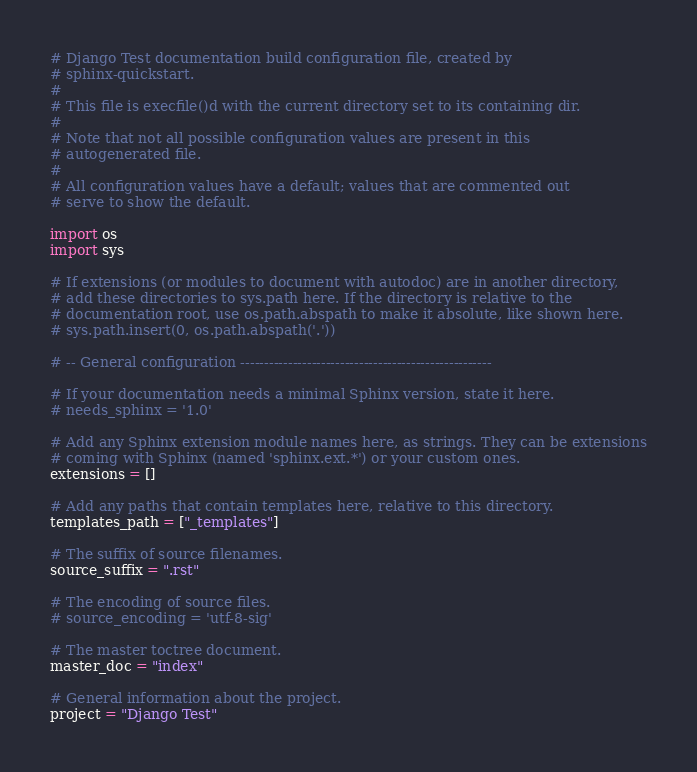Convert code to text. <code><loc_0><loc_0><loc_500><loc_500><_Python_># Django Test documentation build configuration file, created by
# sphinx-quickstart.
#
# This file is execfile()d with the current directory set to its containing dir.
#
# Note that not all possible configuration values are present in this
# autogenerated file.
#
# All configuration values have a default; values that are commented out
# serve to show the default.

import os
import sys

# If extensions (or modules to document with autodoc) are in another directory,
# add these directories to sys.path here. If the directory is relative to the
# documentation root, use os.path.abspath to make it absolute, like shown here.
# sys.path.insert(0, os.path.abspath('.'))

# -- General configuration -----------------------------------------------------

# If your documentation needs a minimal Sphinx version, state it here.
# needs_sphinx = '1.0'

# Add any Sphinx extension module names here, as strings. They can be extensions
# coming with Sphinx (named 'sphinx.ext.*') or your custom ones.
extensions = []

# Add any paths that contain templates here, relative to this directory.
templates_path = ["_templates"]

# The suffix of source filenames.
source_suffix = ".rst"

# The encoding of source files.
# source_encoding = 'utf-8-sig'

# The master toctree document.
master_doc = "index"

# General information about the project.
project = "Django Test"</code> 